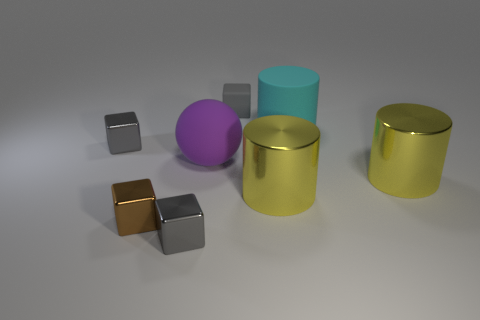Subtract all cyan spheres. How many gray cubes are left? 3 Add 2 large green matte balls. How many objects exist? 10 Subtract all spheres. How many objects are left? 7 Subtract 1 yellow cylinders. How many objects are left? 7 Subtract all gray cubes. Subtract all brown things. How many objects are left? 4 Add 8 tiny brown shiny things. How many tiny brown shiny things are left? 9 Add 4 purple matte objects. How many purple matte objects exist? 5 